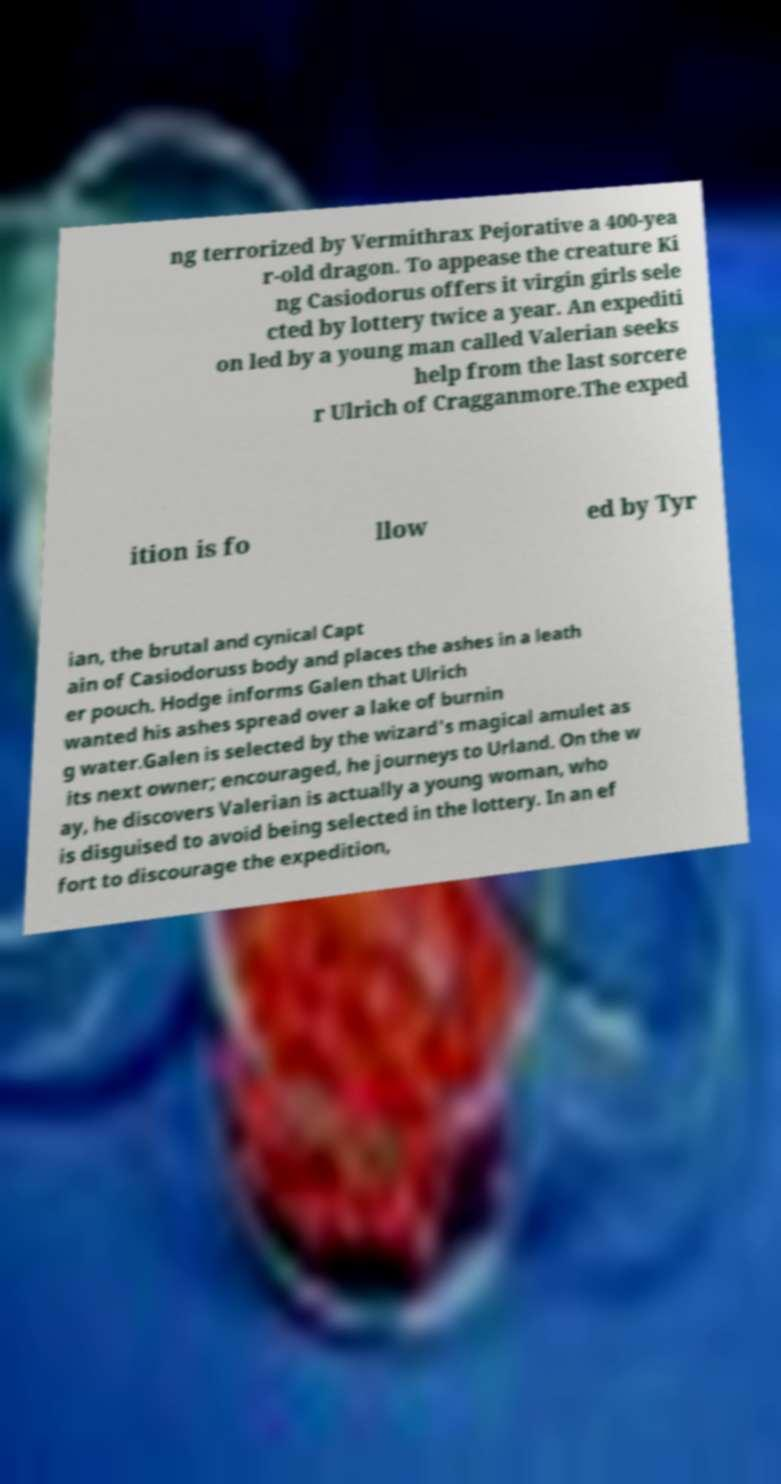Could you assist in decoding the text presented in this image and type it out clearly? ng terrorized by Vermithrax Pejorative a 400-yea r-old dragon. To appease the creature Ki ng Casiodorus offers it virgin girls sele cted by lottery twice a year. An expediti on led by a young man called Valerian seeks help from the last sorcere r Ulrich of Cragganmore.The exped ition is fo llow ed by Tyr ian, the brutal and cynical Capt ain of Casiodoruss body and places the ashes in a leath er pouch. Hodge informs Galen that Ulrich wanted his ashes spread over a lake of burnin g water.Galen is selected by the wizard's magical amulet as its next owner; encouraged, he journeys to Urland. On the w ay, he discovers Valerian is actually a young woman, who is disguised to avoid being selected in the lottery. In an ef fort to discourage the expedition, 